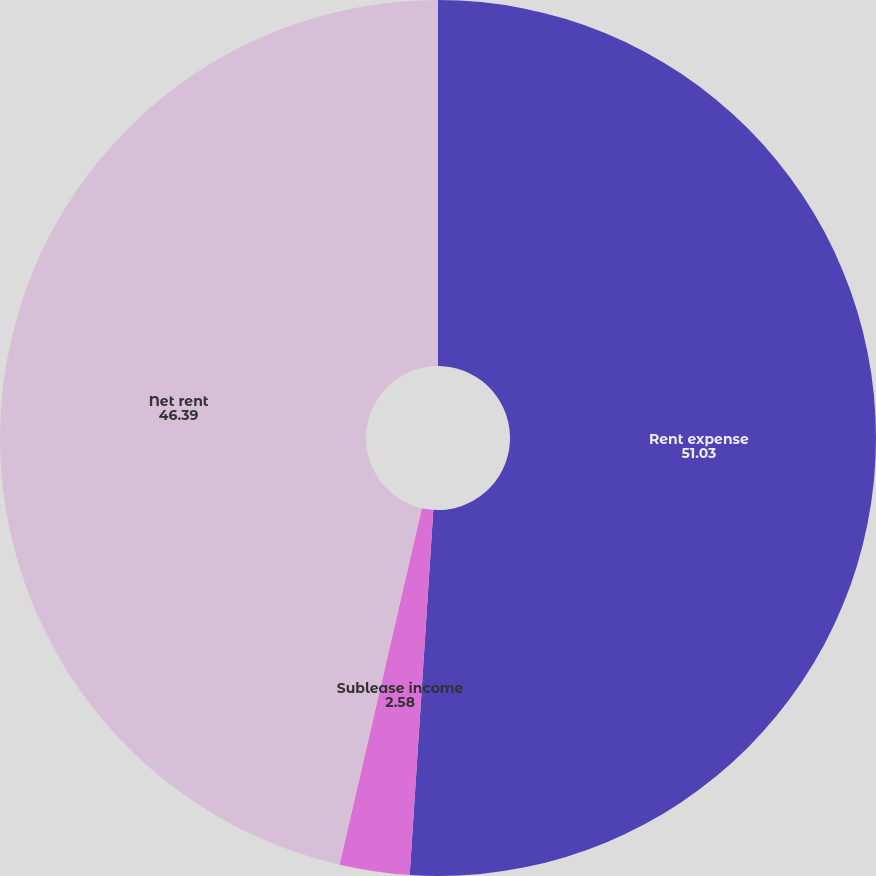Convert chart. <chart><loc_0><loc_0><loc_500><loc_500><pie_chart><fcel>Rent expense<fcel>Sublease income<fcel>Net rent<nl><fcel>51.03%<fcel>2.58%<fcel>46.39%<nl></chart> 